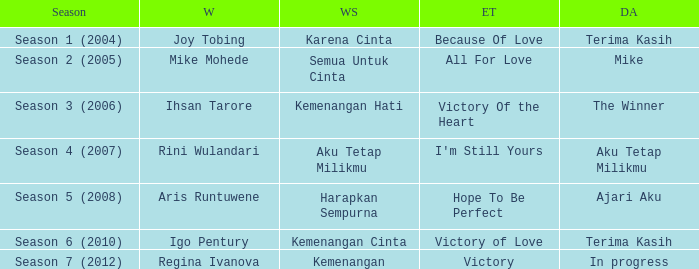Which English winning song had the winner aris runtuwene? Hope To Be Perfect. 